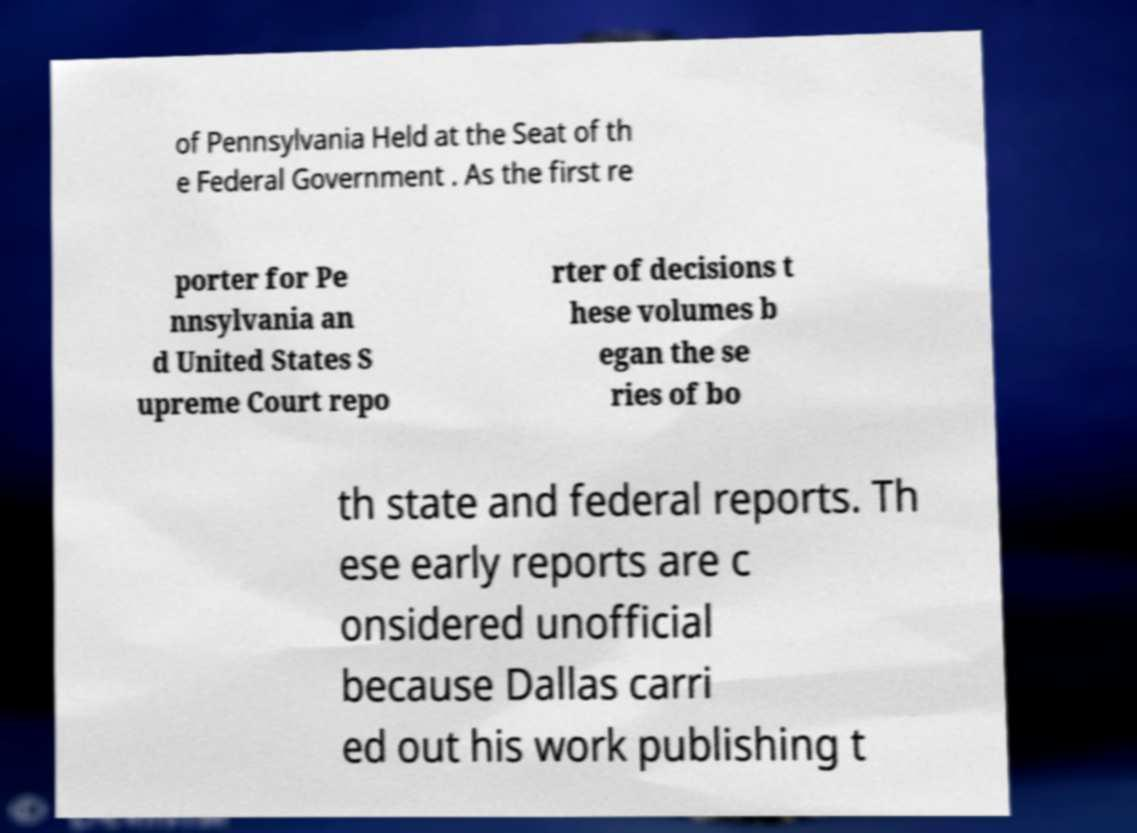Please read and relay the text visible in this image. What does it say? of Pennsylvania Held at the Seat of th e Federal Government . As the first re porter for Pe nnsylvania an d United States S upreme Court repo rter of decisions t hese volumes b egan the se ries of bo th state and federal reports. Th ese early reports are c onsidered unofficial because Dallas carri ed out his work publishing t 